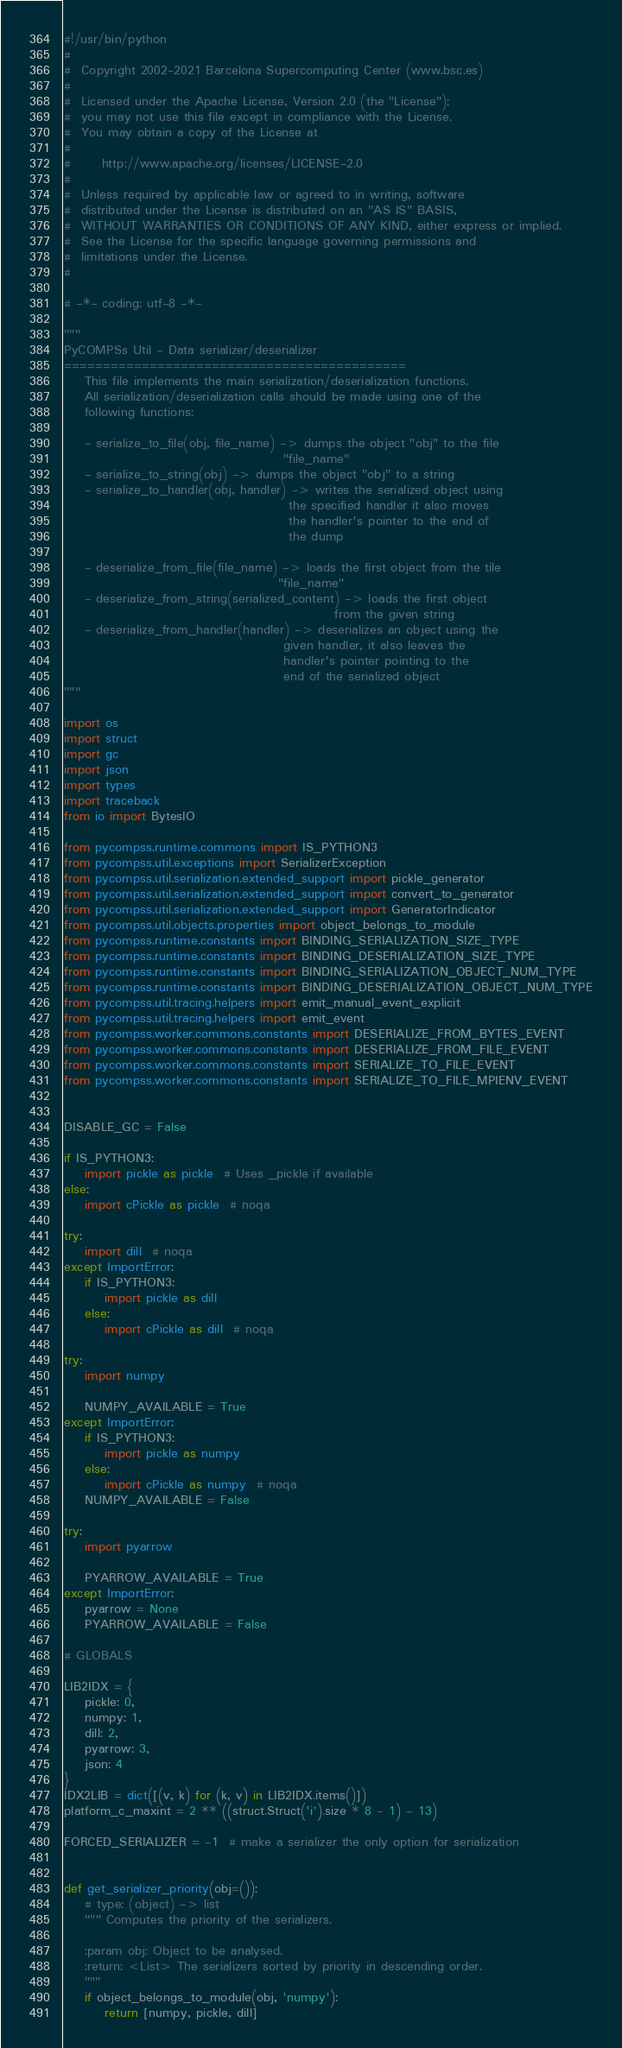<code> <loc_0><loc_0><loc_500><loc_500><_Python_>#!/usr/bin/python
#
#  Copyright 2002-2021 Barcelona Supercomputing Center (www.bsc.es)
#
#  Licensed under the Apache License, Version 2.0 (the "License");
#  you may not use this file except in compliance with the License.
#  You may obtain a copy of the License at
#
#      http://www.apache.org/licenses/LICENSE-2.0
#
#  Unless required by applicable law or agreed to in writing, software
#  distributed under the License is distributed on an "AS IS" BASIS,
#  WITHOUT WARRANTIES OR CONDITIONS OF ANY KIND, either express or implied.
#  See the License for the specific language governing permissions and
#  limitations under the License.
#

# -*- coding: utf-8 -*-

"""
PyCOMPSs Util - Data serializer/deserializer
============================================
    This file implements the main serialization/deserialization functions.
    All serialization/deserialization calls should be made using one of the
    following functions:

    - serialize_to_file(obj, file_name) -> dumps the object "obj" to the file
                                           "file_name"
    - serialize_to_string(obj) -> dumps the object "obj" to a string
    - serialize_to_handler(obj, handler) -> writes the serialized object using
                                            the specified handler it also moves
                                            the handler's pointer to the end of
                                            the dump

    - deserialize_from_file(file_name) -> loads the first object from the tile
                                          "file_name"
    - deserialize_from_string(serialized_content) -> loads the first object
                                                     from the given string
    - deserialize_from_handler(handler) -> deserializes an object using the
                                           given handler, it also leaves the
                                           handler's pointer pointing to the
                                           end of the serialized object
"""

import os
import struct
import gc
import json
import types
import traceback
from io import BytesIO

from pycompss.runtime.commons import IS_PYTHON3
from pycompss.util.exceptions import SerializerException
from pycompss.util.serialization.extended_support import pickle_generator
from pycompss.util.serialization.extended_support import convert_to_generator
from pycompss.util.serialization.extended_support import GeneratorIndicator
from pycompss.util.objects.properties import object_belongs_to_module
from pycompss.runtime.constants import BINDING_SERIALIZATION_SIZE_TYPE
from pycompss.runtime.constants import BINDING_DESERIALIZATION_SIZE_TYPE
from pycompss.runtime.constants import BINDING_SERIALIZATION_OBJECT_NUM_TYPE
from pycompss.runtime.constants import BINDING_DESERIALIZATION_OBJECT_NUM_TYPE
from pycompss.util.tracing.helpers import emit_manual_event_explicit
from pycompss.util.tracing.helpers import emit_event
from pycompss.worker.commons.constants import DESERIALIZE_FROM_BYTES_EVENT
from pycompss.worker.commons.constants import DESERIALIZE_FROM_FILE_EVENT
from pycompss.worker.commons.constants import SERIALIZE_TO_FILE_EVENT
from pycompss.worker.commons.constants import SERIALIZE_TO_FILE_MPIENV_EVENT


DISABLE_GC = False

if IS_PYTHON3:
    import pickle as pickle  # Uses _pickle if available
else:
    import cPickle as pickle  # noqa

try:
    import dill  # noqa
except ImportError:
    if IS_PYTHON3:
        import pickle as dill
    else:
        import cPickle as dill  # noqa

try:
    import numpy

    NUMPY_AVAILABLE = True
except ImportError:
    if IS_PYTHON3:
        import pickle as numpy
    else:
        import cPickle as numpy  # noqa
    NUMPY_AVAILABLE = False

try:
    import pyarrow

    PYARROW_AVAILABLE = True
except ImportError:
    pyarrow = None
    PYARROW_AVAILABLE = False

# GLOBALS

LIB2IDX = {
    pickle: 0,
    numpy: 1,
    dill: 2,
    pyarrow: 3,
    json: 4
}
IDX2LIB = dict([(v, k) for (k, v) in LIB2IDX.items()])
platform_c_maxint = 2 ** ((struct.Struct('i').size * 8 - 1) - 13)

FORCED_SERIALIZER = -1  # make a serializer the only option for serialization


def get_serializer_priority(obj=()):
    # type: (object) -> list
    """ Computes the priority of the serializers.

    :param obj: Object to be analysed.
    :return: <List> The serializers sorted by priority in descending order.
    """
    if object_belongs_to_module(obj, 'numpy'):
        return [numpy, pickle, dill]</code> 